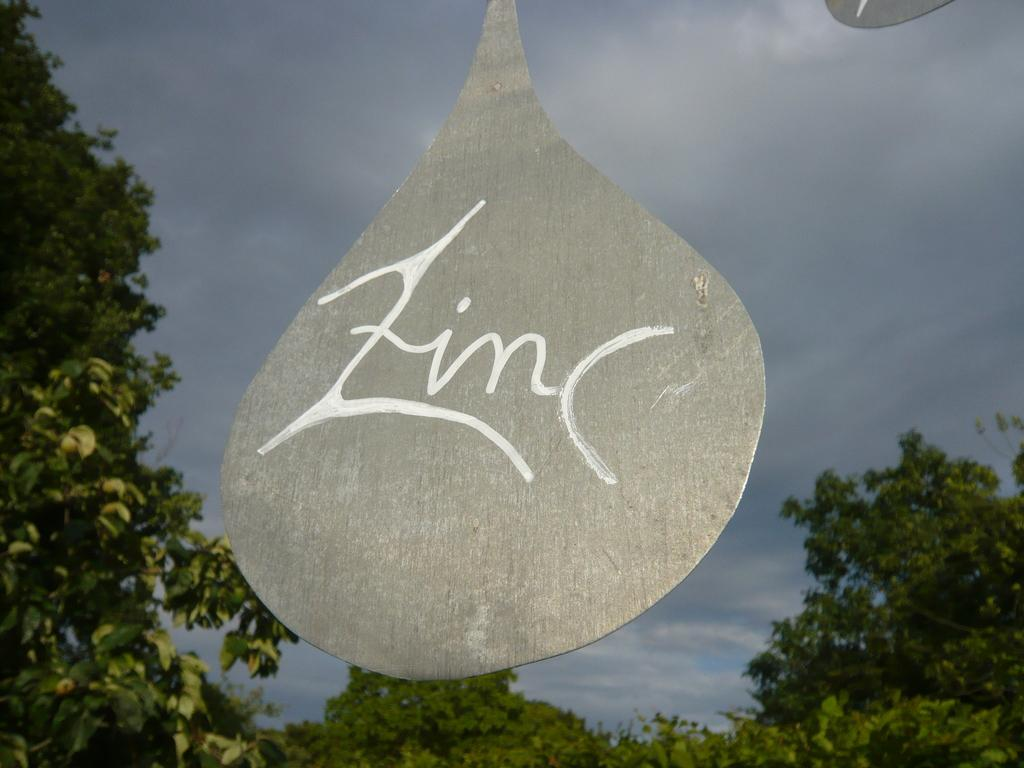What is the main object in the center of the picture? There is an iron object in the center of the picture. What can be seen in the background of the image? There are trees in the background of the image. How would you describe the sky in the image? The sky is cloudy in the image. What type of straw is used to hold up the tin object in the image? There is no tin object or straw present in the image. 